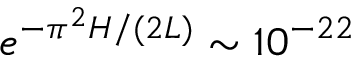Convert formula to latex. <formula><loc_0><loc_0><loc_500><loc_500>e ^ { - \pi ^ { 2 } H / ( 2 L ) } \sim 1 0 ^ { - 2 2 }</formula> 